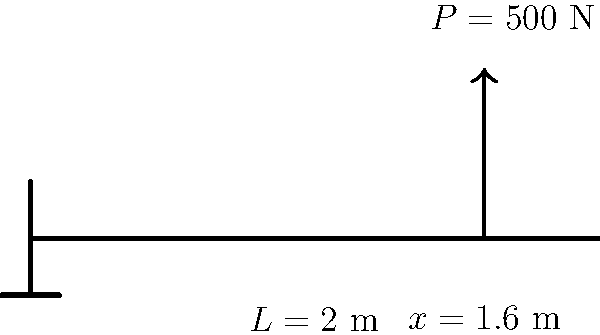A cantilever beam of length $L = 2$ m is subjected to a point load $P = 500$ N at a distance of $x = 1.6$ m from the fixed end. Given that the beam has a rectangular cross-section with width $b = 50$ mm and height $h = 100$ mm, calculate the maximum bending stress $\sigma_{max}$ in the beam. Use the formula $\sigma_{max} = \frac{Mc}{I}$, where $M$ is the bending moment, $c$ is the distance from the neutral axis to the outermost fiber, and $I$ is the moment of inertia of the cross-section. To solve this problem, we'll follow these steps:

1. Calculate the bending moment $M$ at the fixed end:
   $M = P(L-x) = 500 \text{ N} (2 \text{ m} - 1.6 \text{ m}) = 200 \text{ N}\cdot\text{m}$

2. Calculate the distance $c$ from the neutral axis to the outermost fiber:
   $c = \frac{h}{2} = \frac{100 \text{ mm}}{2} = 50 \text{ mm} = 0.05 \text{ m}$

3. Calculate the moment of inertia $I$ for a rectangular cross-section:
   $I = \frac{bh^3}{12} = \frac{50 \text{ mm} \cdot (100 \text{ mm})^3}{12} = 4.17 \times 10^6 \text{ mm}^4 = 4.17 \times 10^{-6} \text{ m}^4$

4. Apply the formula for maximum bending stress:
   $\sigma_{max} = \frac{Mc}{I} = \frac{200 \text{ N}\cdot\text{m} \cdot 0.05 \text{ m}}{4.17 \times 10^{-6} \text{ m}^4} = 2.40 \times 10^6 \text{ Pa} = 2.40 \text{ MPa}$
Answer: $2.40 \text{ MPa}$ 